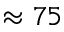Convert formula to latex. <formula><loc_0><loc_0><loc_500><loc_500>\approx 7 5</formula> 